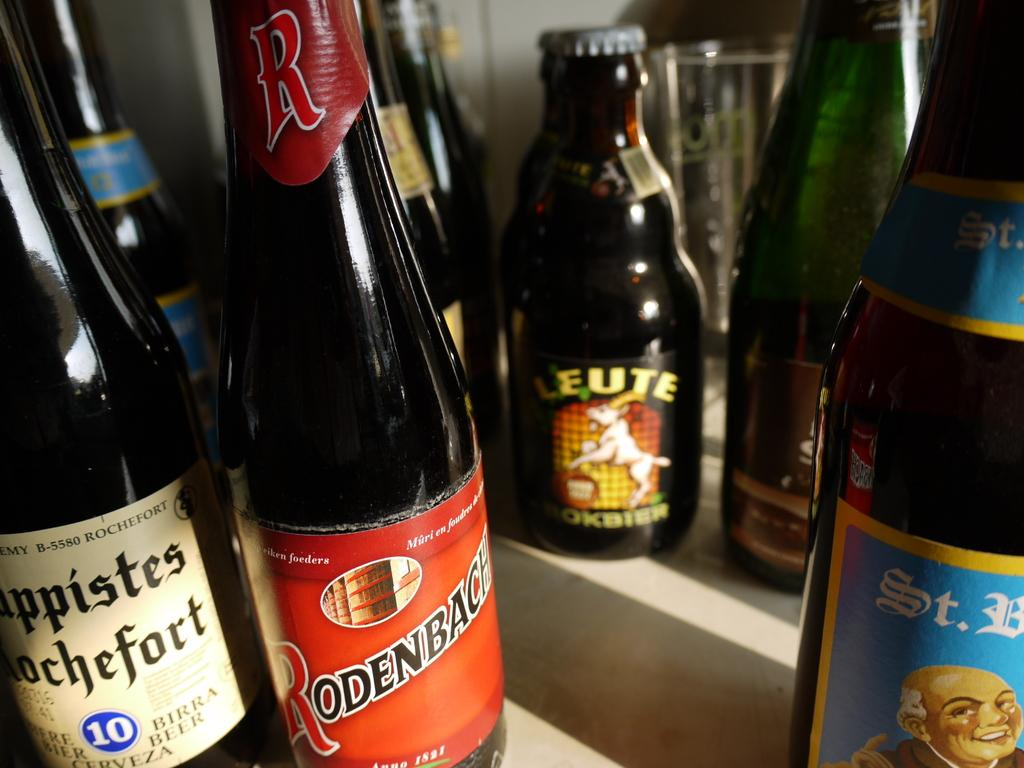<image>
Share a concise interpretation of the image provided. Several wines are available including a bottle of Rodenbach. 